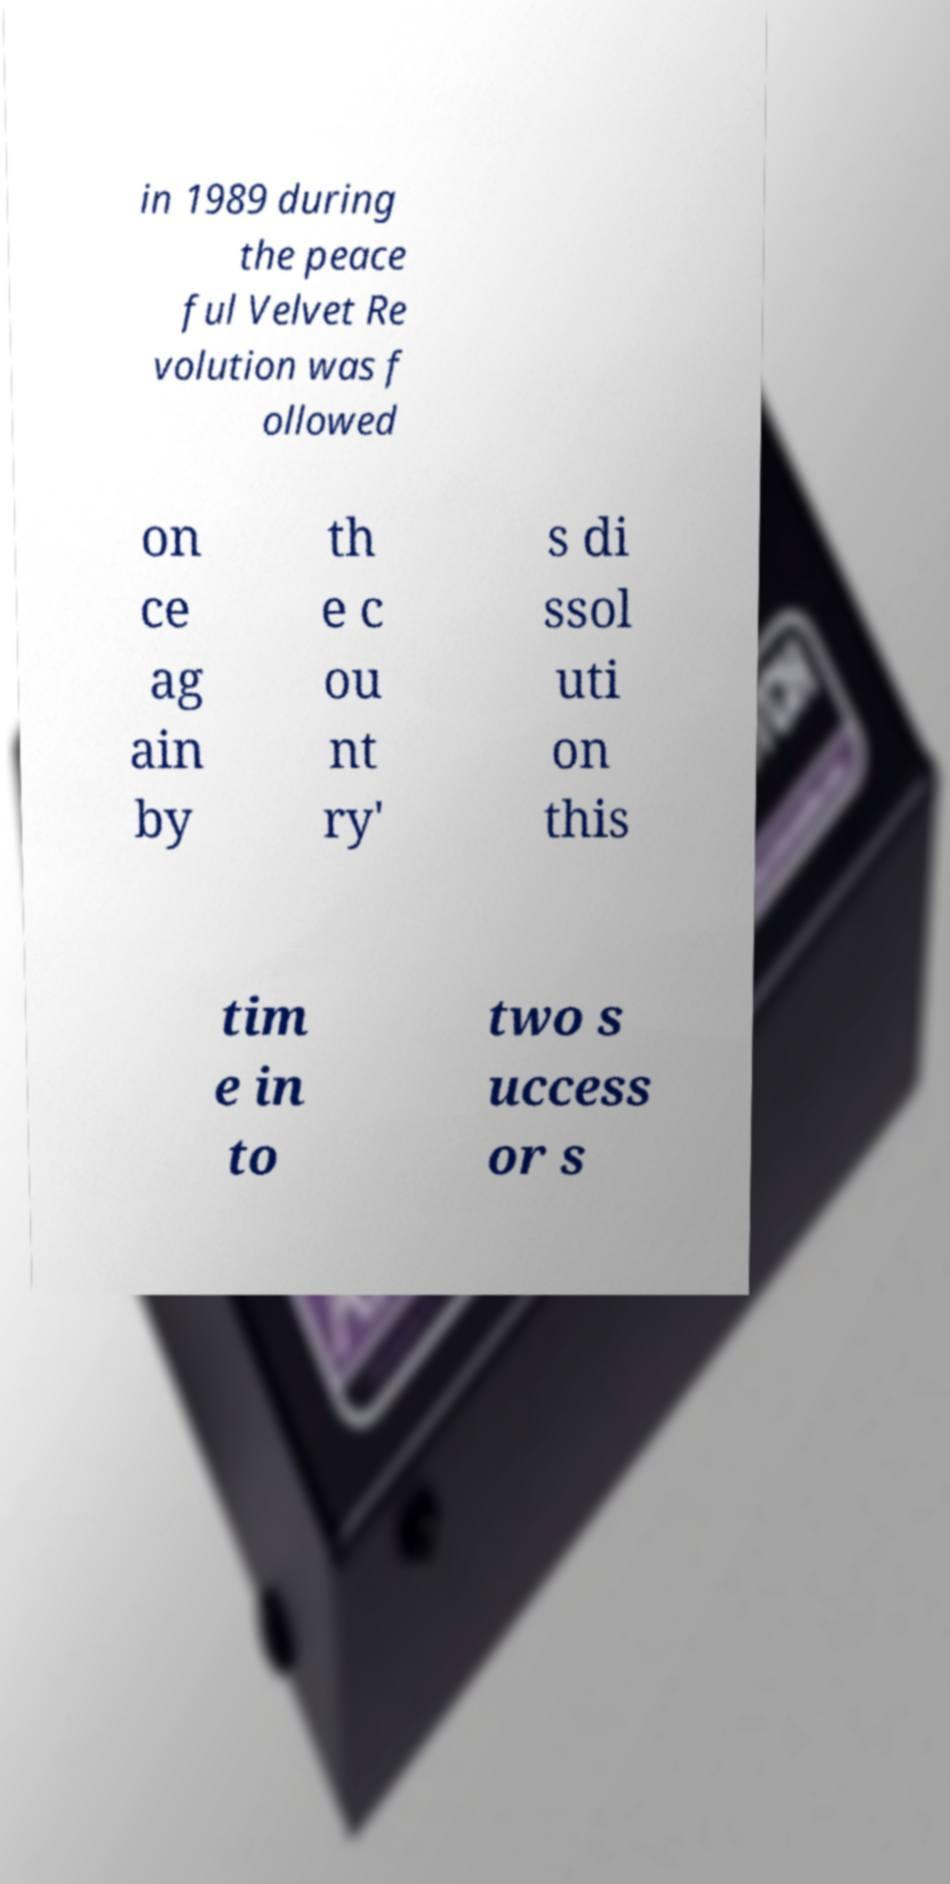Can you read and provide the text displayed in the image?This photo seems to have some interesting text. Can you extract and type it out for me? in 1989 during the peace ful Velvet Re volution was f ollowed on ce ag ain by th e c ou nt ry' s di ssol uti on this tim e in to two s uccess or s 